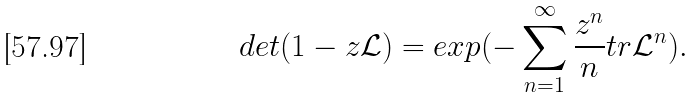<formula> <loc_0><loc_0><loc_500><loc_500>d e t ( 1 - z \mathcal { L } ) = e x p ( - \sum _ { n = 1 } ^ { \infty } \frac { z ^ { n } } { n } t r \mathcal { L } ^ { n } ) .</formula> 